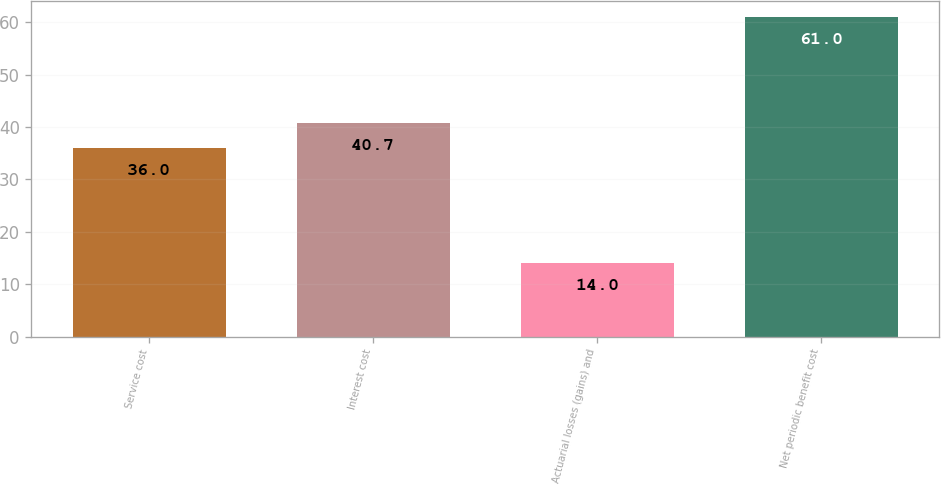Convert chart. <chart><loc_0><loc_0><loc_500><loc_500><bar_chart><fcel>Service cost<fcel>Interest cost<fcel>Actuarial losses (gains) and<fcel>Net periodic benefit cost<nl><fcel>36<fcel>40.7<fcel>14<fcel>61<nl></chart> 